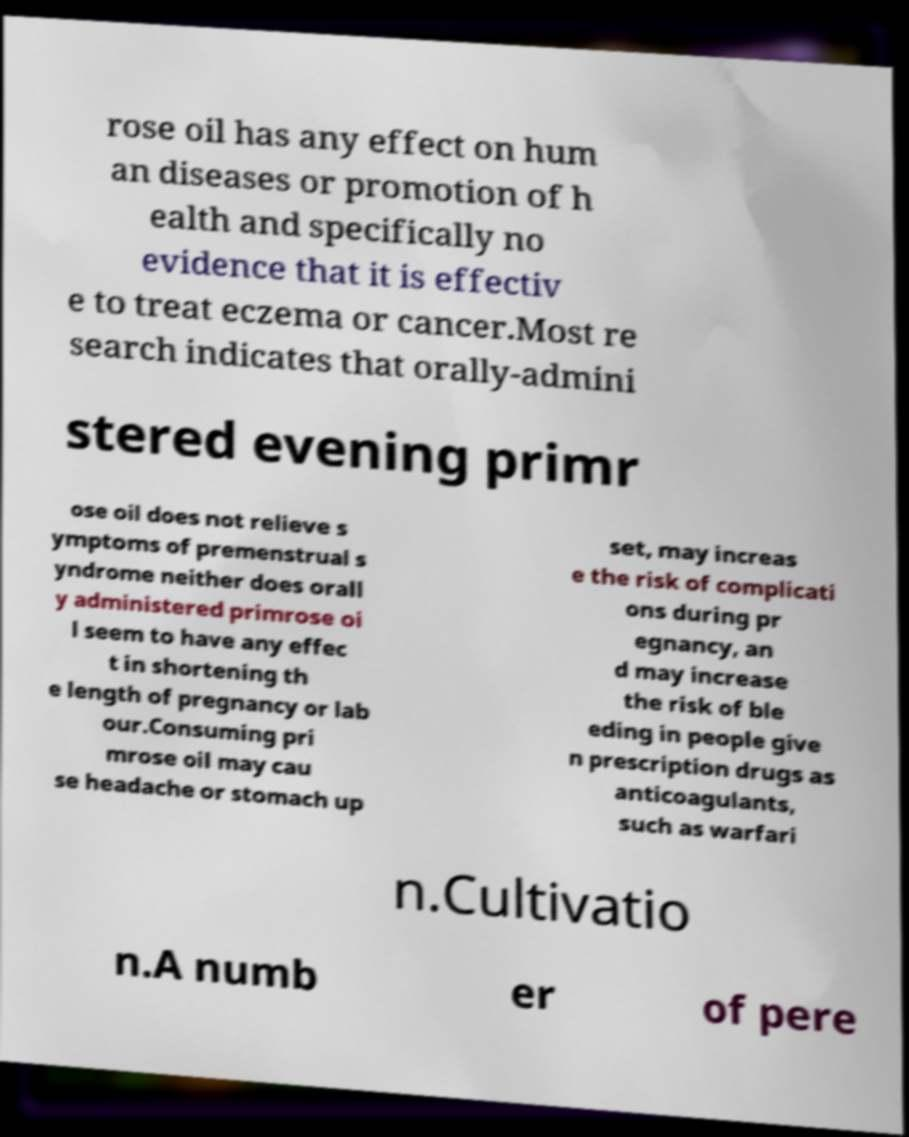Can you read and provide the text displayed in the image?This photo seems to have some interesting text. Can you extract and type it out for me? rose oil has any effect on hum an diseases or promotion of h ealth and specifically no evidence that it is effectiv e to treat eczema or cancer.Most re search indicates that orally-admini stered evening primr ose oil does not relieve s ymptoms of premenstrual s yndrome neither does orall y administered primrose oi l seem to have any effec t in shortening th e length of pregnancy or lab our.Consuming pri mrose oil may cau se headache or stomach up set, may increas e the risk of complicati ons during pr egnancy, an d may increase the risk of ble eding in people give n prescription drugs as anticoagulants, such as warfari n.Cultivatio n.A numb er of pere 